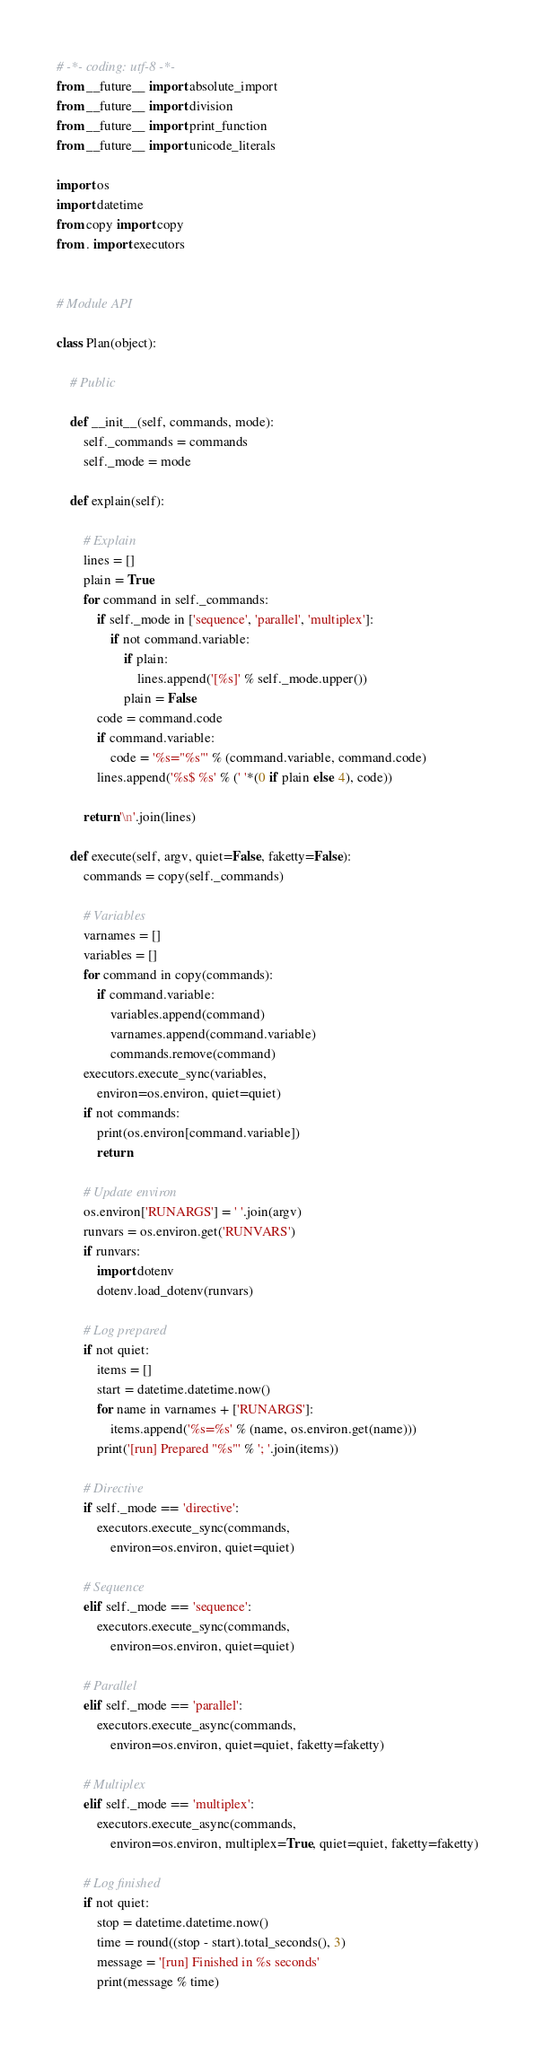<code> <loc_0><loc_0><loc_500><loc_500><_Python_># -*- coding: utf-8 -*-
from __future__ import absolute_import
from __future__ import division
from __future__ import print_function
from __future__ import unicode_literals

import os
import datetime
from copy import copy
from . import executors


# Module API

class Plan(object):

    # Public

    def __init__(self, commands, mode):
        self._commands = commands
        self._mode = mode

    def explain(self):

        # Explain
        lines = []
        plain = True
        for command in self._commands:
            if self._mode in ['sequence', 'parallel', 'multiplex']:
                if not command.variable:
                    if plain:
                        lines.append('[%s]' % self._mode.upper())
                    plain = False
            code = command.code
            if command.variable:
                code = '%s="%s"' % (command.variable, command.code)
            lines.append('%s$ %s' % (' '*(0 if plain else 4), code))

        return '\n'.join(lines)

    def execute(self, argv, quiet=False, faketty=False):
        commands = copy(self._commands)

        # Variables
        varnames = []
        variables = []
        for command in copy(commands):
            if command.variable:
                variables.append(command)
                varnames.append(command.variable)
                commands.remove(command)
        executors.execute_sync(variables,
            environ=os.environ, quiet=quiet)
        if not commands:
            print(os.environ[command.variable])
            return

        # Update environ
        os.environ['RUNARGS'] = ' '.join(argv)
        runvars = os.environ.get('RUNVARS')
        if runvars:
            import dotenv
            dotenv.load_dotenv(runvars)

        # Log prepared
        if not quiet:
            items = []
            start = datetime.datetime.now()
            for name in varnames + ['RUNARGS']:
                items.append('%s=%s' % (name, os.environ.get(name)))
            print('[run] Prepared "%s"' % '; '.join(items))

        # Directive
        if self._mode == 'directive':
            executors.execute_sync(commands,
                environ=os.environ, quiet=quiet)

        # Sequence
        elif self._mode == 'sequence':
            executors.execute_sync(commands,
                environ=os.environ, quiet=quiet)

        # Parallel
        elif self._mode == 'parallel':
            executors.execute_async(commands,
                environ=os.environ, quiet=quiet, faketty=faketty)

        # Multiplex
        elif self._mode == 'multiplex':
            executors.execute_async(commands,
                environ=os.environ, multiplex=True, quiet=quiet, faketty=faketty)

        # Log finished
        if not quiet:
            stop = datetime.datetime.now()
            time = round((stop - start).total_seconds(), 3)
            message = '[run] Finished in %s seconds'
            print(message % time)
</code> 